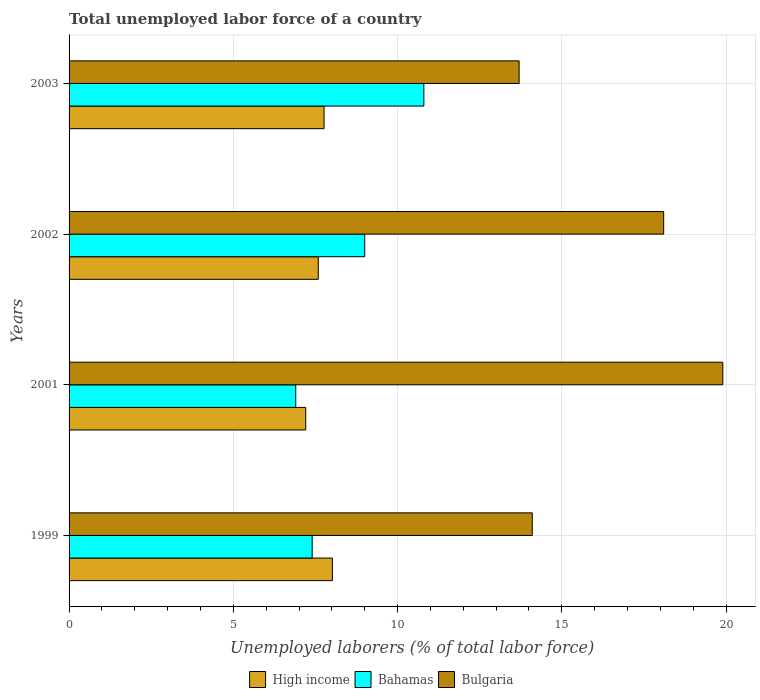How many groups of bars are there?
Make the answer very short. 4. Are the number of bars per tick equal to the number of legend labels?
Your answer should be compact. Yes. Are the number of bars on each tick of the Y-axis equal?
Provide a succinct answer. Yes. How many bars are there on the 4th tick from the top?
Give a very brief answer. 3. How many bars are there on the 4th tick from the bottom?
Make the answer very short. 3. What is the total unemployed labor force in High income in 2003?
Offer a very short reply. 7.76. Across all years, what is the maximum total unemployed labor force in Bahamas?
Provide a short and direct response. 10.8. Across all years, what is the minimum total unemployed labor force in Bulgaria?
Keep it short and to the point. 13.7. In which year was the total unemployed labor force in Bulgaria maximum?
Your answer should be very brief. 2001. What is the total total unemployed labor force in Bulgaria in the graph?
Your answer should be compact. 65.8. What is the difference between the total unemployed labor force in Bulgaria in 2001 and that in 2002?
Provide a succinct answer. 1.8. What is the difference between the total unemployed labor force in High income in 2001 and the total unemployed labor force in Bahamas in 2002?
Make the answer very short. -1.8. What is the average total unemployed labor force in High income per year?
Your response must be concise. 7.64. In the year 2001, what is the difference between the total unemployed labor force in Bahamas and total unemployed labor force in High income?
Keep it short and to the point. -0.3. In how many years, is the total unemployed labor force in High income greater than 16 %?
Give a very brief answer. 0. What is the ratio of the total unemployed labor force in High income in 2001 to that in 2003?
Ensure brevity in your answer.  0.93. Is the total unemployed labor force in Bulgaria in 2001 less than that in 2003?
Give a very brief answer. No. What is the difference between the highest and the second highest total unemployed labor force in Bahamas?
Provide a succinct answer. 1.8. What is the difference between the highest and the lowest total unemployed labor force in Bahamas?
Ensure brevity in your answer.  3.9. In how many years, is the total unemployed labor force in High income greater than the average total unemployed labor force in High income taken over all years?
Your response must be concise. 2. Is the sum of the total unemployed labor force in High income in 1999 and 2001 greater than the maximum total unemployed labor force in Bahamas across all years?
Offer a terse response. Yes. What does the 2nd bar from the top in 2003 represents?
Offer a terse response. Bahamas. What does the 3rd bar from the bottom in 2002 represents?
Offer a very short reply. Bulgaria. What is the difference between two consecutive major ticks on the X-axis?
Your response must be concise. 5. Are the values on the major ticks of X-axis written in scientific E-notation?
Make the answer very short. No. Does the graph contain any zero values?
Your answer should be compact. No. Does the graph contain grids?
Your response must be concise. Yes. Where does the legend appear in the graph?
Give a very brief answer. Bottom center. How are the legend labels stacked?
Offer a very short reply. Horizontal. What is the title of the graph?
Give a very brief answer. Total unemployed labor force of a country. What is the label or title of the X-axis?
Offer a very short reply. Unemployed laborers (% of total labor force). What is the Unemployed laborers (% of total labor force) in High income in 1999?
Your answer should be compact. 8.02. What is the Unemployed laborers (% of total labor force) in Bahamas in 1999?
Make the answer very short. 7.4. What is the Unemployed laborers (% of total labor force) in Bulgaria in 1999?
Your answer should be compact. 14.1. What is the Unemployed laborers (% of total labor force) of High income in 2001?
Your answer should be very brief. 7.2. What is the Unemployed laborers (% of total labor force) of Bahamas in 2001?
Your answer should be compact. 6.9. What is the Unemployed laborers (% of total labor force) of Bulgaria in 2001?
Keep it short and to the point. 19.9. What is the Unemployed laborers (% of total labor force) of High income in 2002?
Give a very brief answer. 7.59. What is the Unemployed laborers (% of total labor force) of Bulgaria in 2002?
Give a very brief answer. 18.1. What is the Unemployed laborers (% of total labor force) in High income in 2003?
Provide a succinct answer. 7.76. What is the Unemployed laborers (% of total labor force) of Bahamas in 2003?
Your answer should be very brief. 10.8. What is the Unemployed laborers (% of total labor force) of Bulgaria in 2003?
Your answer should be compact. 13.7. Across all years, what is the maximum Unemployed laborers (% of total labor force) in High income?
Your answer should be compact. 8.02. Across all years, what is the maximum Unemployed laborers (% of total labor force) in Bahamas?
Make the answer very short. 10.8. Across all years, what is the maximum Unemployed laborers (% of total labor force) of Bulgaria?
Your answer should be compact. 19.9. Across all years, what is the minimum Unemployed laborers (% of total labor force) of High income?
Your response must be concise. 7.2. Across all years, what is the minimum Unemployed laborers (% of total labor force) of Bahamas?
Ensure brevity in your answer.  6.9. Across all years, what is the minimum Unemployed laborers (% of total labor force) of Bulgaria?
Your answer should be compact. 13.7. What is the total Unemployed laborers (% of total labor force) in High income in the graph?
Your answer should be very brief. 30.57. What is the total Unemployed laborers (% of total labor force) in Bahamas in the graph?
Provide a short and direct response. 34.1. What is the total Unemployed laborers (% of total labor force) of Bulgaria in the graph?
Make the answer very short. 65.8. What is the difference between the Unemployed laborers (% of total labor force) in High income in 1999 and that in 2001?
Offer a very short reply. 0.81. What is the difference between the Unemployed laborers (% of total labor force) in Bahamas in 1999 and that in 2001?
Offer a very short reply. 0.5. What is the difference between the Unemployed laborers (% of total labor force) in Bulgaria in 1999 and that in 2001?
Offer a very short reply. -5.8. What is the difference between the Unemployed laborers (% of total labor force) of High income in 1999 and that in 2002?
Your answer should be compact. 0.43. What is the difference between the Unemployed laborers (% of total labor force) in Bulgaria in 1999 and that in 2002?
Your response must be concise. -4. What is the difference between the Unemployed laborers (% of total labor force) of High income in 1999 and that in 2003?
Provide a succinct answer. 0.25. What is the difference between the Unemployed laborers (% of total labor force) in Bahamas in 1999 and that in 2003?
Provide a succinct answer. -3.4. What is the difference between the Unemployed laborers (% of total labor force) in High income in 2001 and that in 2002?
Your answer should be very brief. -0.38. What is the difference between the Unemployed laborers (% of total labor force) in Bahamas in 2001 and that in 2002?
Your response must be concise. -2.1. What is the difference between the Unemployed laborers (% of total labor force) in High income in 2001 and that in 2003?
Offer a terse response. -0.56. What is the difference between the Unemployed laborers (% of total labor force) in Bulgaria in 2001 and that in 2003?
Offer a terse response. 6.2. What is the difference between the Unemployed laborers (% of total labor force) of High income in 2002 and that in 2003?
Offer a very short reply. -0.18. What is the difference between the Unemployed laborers (% of total labor force) in Bahamas in 2002 and that in 2003?
Keep it short and to the point. -1.8. What is the difference between the Unemployed laborers (% of total labor force) in High income in 1999 and the Unemployed laborers (% of total labor force) in Bahamas in 2001?
Offer a very short reply. 1.12. What is the difference between the Unemployed laborers (% of total labor force) in High income in 1999 and the Unemployed laborers (% of total labor force) in Bulgaria in 2001?
Provide a succinct answer. -11.88. What is the difference between the Unemployed laborers (% of total labor force) of High income in 1999 and the Unemployed laborers (% of total labor force) of Bahamas in 2002?
Ensure brevity in your answer.  -0.98. What is the difference between the Unemployed laborers (% of total labor force) of High income in 1999 and the Unemployed laborers (% of total labor force) of Bulgaria in 2002?
Your answer should be compact. -10.08. What is the difference between the Unemployed laborers (% of total labor force) of Bahamas in 1999 and the Unemployed laborers (% of total labor force) of Bulgaria in 2002?
Give a very brief answer. -10.7. What is the difference between the Unemployed laborers (% of total labor force) of High income in 1999 and the Unemployed laborers (% of total labor force) of Bahamas in 2003?
Keep it short and to the point. -2.78. What is the difference between the Unemployed laborers (% of total labor force) of High income in 1999 and the Unemployed laborers (% of total labor force) of Bulgaria in 2003?
Your answer should be very brief. -5.68. What is the difference between the Unemployed laborers (% of total labor force) in Bahamas in 1999 and the Unemployed laborers (% of total labor force) in Bulgaria in 2003?
Make the answer very short. -6.3. What is the difference between the Unemployed laborers (% of total labor force) of High income in 2001 and the Unemployed laborers (% of total labor force) of Bahamas in 2002?
Make the answer very short. -1.8. What is the difference between the Unemployed laborers (% of total labor force) of High income in 2001 and the Unemployed laborers (% of total labor force) of Bulgaria in 2002?
Provide a succinct answer. -10.9. What is the difference between the Unemployed laborers (% of total labor force) in High income in 2001 and the Unemployed laborers (% of total labor force) in Bahamas in 2003?
Provide a succinct answer. -3.6. What is the difference between the Unemployed laborers (% of total labor force) of High income in 2001 and the Unemployed laborers (% of total labor force) of Bulgaria in 2003?
Make the answer very short. -6.5. What is the difference between the Unemployed laborers (% of total labor force) of High income in 2002 and the Unemployed laborers (% of total labor force) of Bahamas in 2003?
Your answer should be very brief. -3.21. What is the difference between the Unemployed laborers (% of total labor force) in High income in 2002 and the Unemployed laborers (% of total labor force) in Bulgaria in 2003?
Provide a short and direct response. -6.11. What is the difference between the Unemployed laborers (% of total labor force) in Bahamas in 2002 and the Unemployed laborers (% of total labor force) in Bulgaria in 2003?
Your answer should be compact. -4.7. What is the average Unemployed laborers (% of total labor force) of High income per year?
Your response must be concise. 7.64. What is the average Unemployed laborers (% of total labor force) of Bahamas per year?
Offer a terse response. 8.53. What is the average Unemployed laborers (% of total labor force) of Bulgaria per year?
Provide a succinct answer. 16.45. In the year 1999, what is the difference between the Unemployed laborers (% of total labor force) in High income and Unemployed laborers (% of total labor force) in Bahamas?
Offer a very short reply. 0.62. In the year 1999, what is the difference between the Unemployed laborers (% of total labor force) in High income and Unemployed laborers (% of total labor force) in Bulgaria?
Keep it short and to the point. -6.08. In the year 1999, what is the difference between the Unemployed laborers (% of total labor force) of Bahamas and Unemployed laborers (% of total labor force) of Bulgaria?
Offer a terse response. -6.7. In the year 2001, what is the difference between the Unemployed laborers (% of total labor force) in High income and Unemployed laborers (% of total labor force) in Bahamas?
Provide a succinct answer. 0.3. In the year 2001, what is the difference between the Unemployed laborers (% of total labor force) of High income and Unemployed laborers (% of total labor force) of Bulgaria?
Your answer should be very brief. -12.7. In the year 2001, what is the difference between the Unemployed laborers (% of total labor force) of Bahamas and Unemployed laborers (% of total labor force) of Bulgaria?
Offer a very short reply. -13. In the year 2002, what is the difference between the Unemployed laborers (% of total labor force) of High income and Unemployed laborers (% of total labor force) of Bahamas?
Your response must be concise. -1.41. In the year 2002, what is the difference between the Unemployed laborers (% of total labor force) in High income and Unemployed laborers (% of total labor force) in Bulgaria?
Ensure brevity in your answer.  -10.51. In the year 2002, what is the difference between the Unemployed laborers (% of total labor force) in Bahamas and Unemployed laborers (% of total labor force) in Bulgaria?
Your answer should be very brief. -9.1. In the year 2003, what is the difference between the Unemployed laborers (% of total labor force) in High income and Unemployed laborers (% of total labor force) in Bahamas?
Your response must be concise. -3.04. In the year 2003, what is the difference between the Unemployed laborers (% of total labor force) in High income and Unemployed laborers (% of total labor force) in Bulgaria?
Provide a succinct answer. -5.94. What is the ratio of the Unemployed laborers (% of total labor force) in High income in 1999 to that in 2001?
Offer a very short reply. 1.11. What is the ratio of the Unemployed laborers (% of total labor force) of Bahamas in 1999 to that in 2001?
Offer a terse response. 1.07. What is the ratio of the Unemployed laborers (% of total labor force) of Bulgaria in 1999 to that in 2001?
Keep it short and to the point. 0.71. What is the ratio of the Unemployed laborers (% of total labor force) in High income in 1999 to that in 2002?
Your response must be concise. 1.06. What is the ratio of the Unemployed laborers (% of total labor force) of Bahamas in 1999 to that in 2002?
Offer a very short reply. 0.82. What is the ratio of the Unemployed laborers (% of total labor force) in Bulgaria in 1999 to that in 2002?
Ensure brevity in your answer.  0.78. What is the ratio of the Unemployed laborers (% of total labor force) in High income in 1999 to that in 2003?
Ensure brevity in your answer.  1.03. What is the ratio of the Unemployed laborers (% of total labor force) in Bahamas in 1999 to that in 2003?
Offer a very short reply. 0.69. What is the ratio of the Unemployed laborers (% of total labor force) of Bulgaria in 1999 to that in 2003?
Provide a short and direct response. 1.03. What is the ratio of the Unemployed laborers (% of total labor force) of High income in 2001 to that in 2002?
Ensure brevity in your answer.  0.95. What is the ratio of the Unemployed laborers (% of total labor force) of Bahamas in 2001 to that in 2002?
Provide a short and direct response. 0.77. What is the ratio of the Unemployed laborers (% of total labor force) in Bulgaria in 2001 to that in 2002?
Keep it short and to the point. 1.1. What is the ratio of the Unemployed laborers (% of total labor force) in High income in 2001 to that in 2003?
Offer a terse response. 0.93. What is the ratio of the Unemployed laborers (% of total labor force) in Bahamas in 2001 to that in 2003?
Provide a succinct answer. 0.64. What is the ratio of the Unemployed laborers (% of total labor force) of Bulgaria in 2001 to that in 2003?
Provide a succinct answer. 1.45. What is the ratio of the Unemployed laborers (% of total labor force) of High income in 2002 to that in 2003?
Make the answer very short. 0.98. What is the ratio of the Unemployed laborers (% of total labor force) of Bahamas in 2002 to that in 2003?
Provide a short and direct response. 0.83. What is the ratio of the Unemployed laborers (% of total labor force) in Bulgaria in 2002 to that in 2003?
Provide a succinct answer. 1.32. What is the difference between the highest and the second highest Unemployed laborers (% of total labor force) in High income?
Provide a short and direct response. 0.25. What is the difference between the highest and the lowest Unemployed laborers (% of total labor force) in High income?
Provide a short and direct response. 0.81. What is the difference between the highest and the lowest Unemployed laborers (% of total labor force) of Bulgaria?
Offer a terse response. 6.2. 